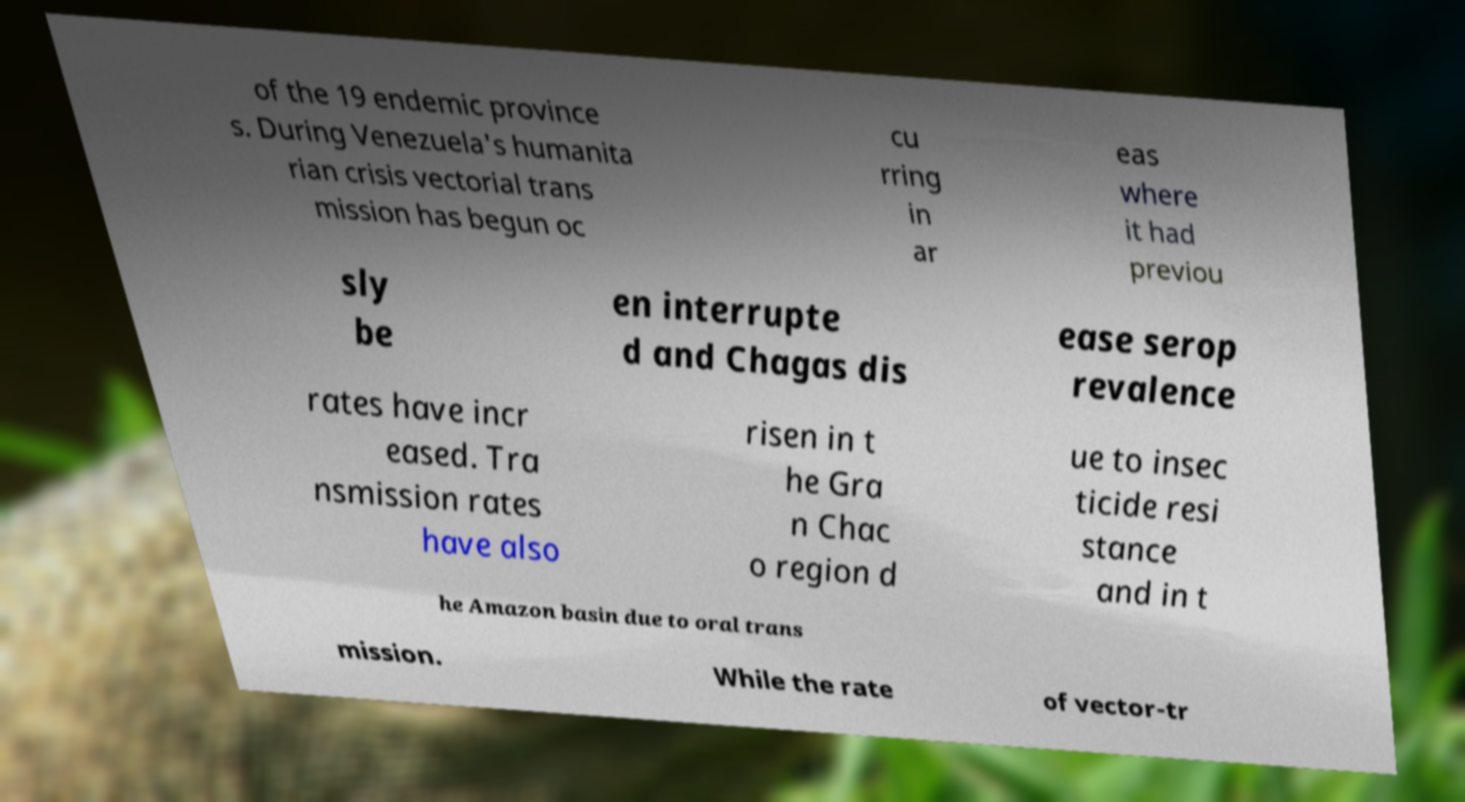Can you read and provide the text displayed in the image?This photo seems to have some interesting text. Can you extract and type it out for me? of the 19 endemic province s. During Venezuela's humanita rian crisis vectorial trans mission has begun oc cu rring in ar eas where it had previou sly be en interrupte d and Chagas dis ease serop revalence rates have incr eased. Tra nsmission rates have also risen in t he Gra n Chac o region d ue to insec ticide resi stance and in t he Amazon basin due to oral trans mission. While the rate of vector-tr 